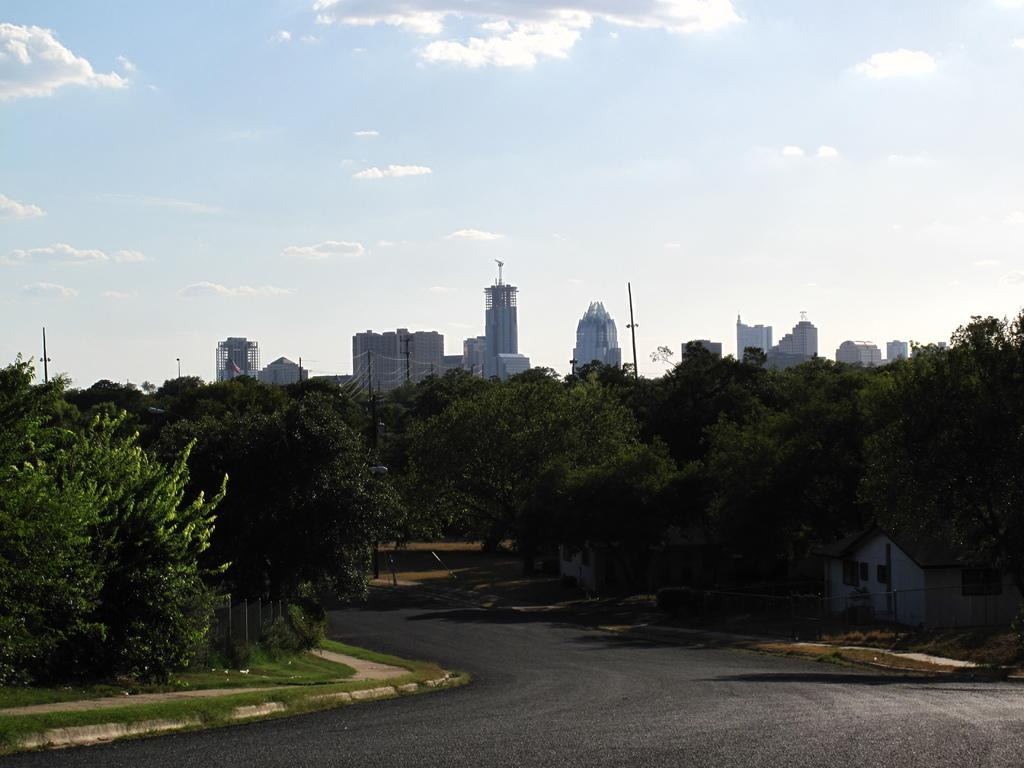What is the main feature of the image? There is a road in the image. What can be seen alongside the road? There are trees around the road. What type of vegetation is present in the image? There are plants in the image. What structures can be seen in the image? There are buildings visible in the image. What is on the list that the children are holding in the image? There is no list or children present in the image. 